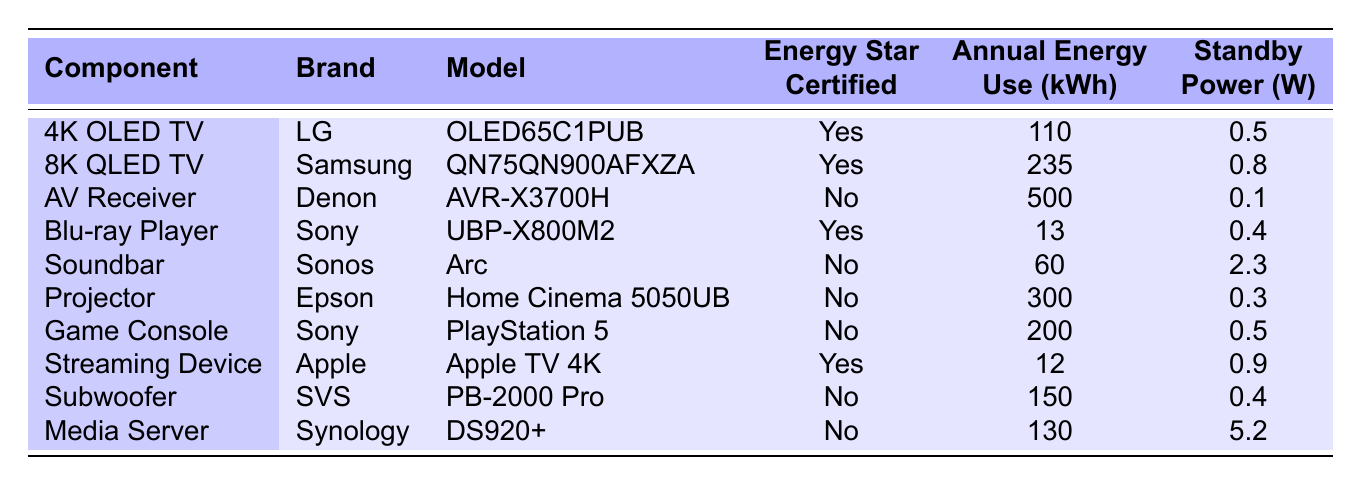What is the annual energy use of the LG 4K OLED TV? The annual energy use value for the LG 4K OLED TV (model OLED65C1PUB) is listed under the "Annual Energy Use (kWh)" column. It shows a value of "110".
Answer: 110 kWh Which component has the highest standby power consumption? By examining the "Standby Power (W)" column, the component with the highest value is the Media Server, which consumes 5.2 watts.
Answer: Media Server Is the Sony Blu-ray Player Energy Star certified? Checking the "Energy Star Certified" column for the Sony Blu-ray Player (model UBP-X800M2), it shows "Yes", indicating that it is Energy Star certified.
Answer: Yes What is the total annual energy usage of all Energy Star certified components? First, identify the Energy Star certified components from the table: LG 4K OLED TV (110 kWh), Samsung 8K QLED TV (235 kWh), Sony Blu-ray Player (13 kWh), and Apple TV 4K (12 kWh). Summing these gives us: 110 + 235 + 13 + 12 = 370 kWh.
Answer: 370 kWh How much more annual energy does the Denon AV Receiver use compared to the Sony Streaming Device? The annual energy usage for the Denon AV Receiver is 500 kWh and for the Apple Streaming Device it is 12 kWh. The difference is calculated by subtracting the two: 500 - 12 = 488 kWh.
Answer: 488 kWh What percentage of the components listed are Energy Star certified? There are 10 components listed in total, with 4 of them being Energy Star certified. To find the percentage, divide the number of certified components by the total number and multiply by 100: (4/10) * 100 = 40%.
Answer: 40% Which brand has the lowest annual energy use and what is it? Looking at the "Annual Energy Use (kWh)" column, the lowest value is 12 kWh from the Apple TV 4K. Thus, the brand with the lowest energy use is Apple.
Answer: Apple with 12 kWh How does the annual energy usage of the Samsung 8K QLED TV compare to that of the Epson Projector? The Samsung 8K QLED TV uses 235 kWh annually while the Epson Projector uses 300 kWh. Therefore, the project uses 300 - 235 = 65 kWh more annually than the Samsung TV.
Answer: 65 kWh Is standby power for the Sonos soundbar higher than that of the LG OLED TV? The standby power for the Sonos Soundbar is 2.3 watts, while the LG OLED TV has a standby power of 0.5 watts. Since 2.3 > 0.5, the Soundbar's standby power is indeed higher.
Answer: Yes Which component has the highest annual energy use and what is that value? By reviewing the "Annual Energy Use (kWh)" column, it's clear that the AV Receiver from Denon has the highest energy usage at 500 kWh.
Answer: AV Receiver, 500 kWh 